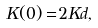Convert formula to latex. <formula><loc_0><loc_0><loc_500><loc_500>K ( 0 { ) = } 2 K d ,</formula> 